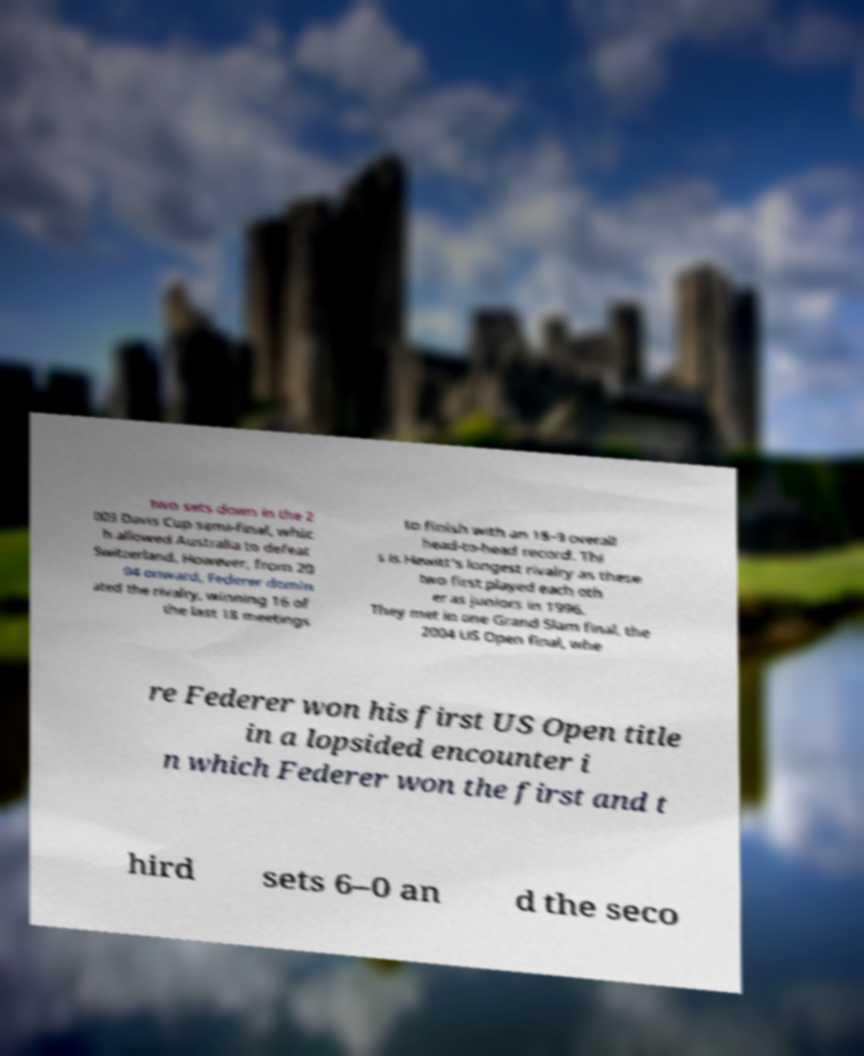Please identify and transcribe the text found in this image. two sets down in the 2 003 Davis Cup semi-final, whic h allowed Australia to defeat Switzerland. However, from 20 04 onward, Federer domin ated the rivalry, winning 16 of the last 18 meetings to finish with an 18–9 overall head-to-head record. Thi s is Hewitt's longest rivalry as these two first played each oth er as juniors in 1996. They met in one Grand Slam final, the 2004 US Open final, whe re Federer won his first US Open title in a lopsided encounter i n which Federer won the first and t hird sets 6–0 an d the seco 